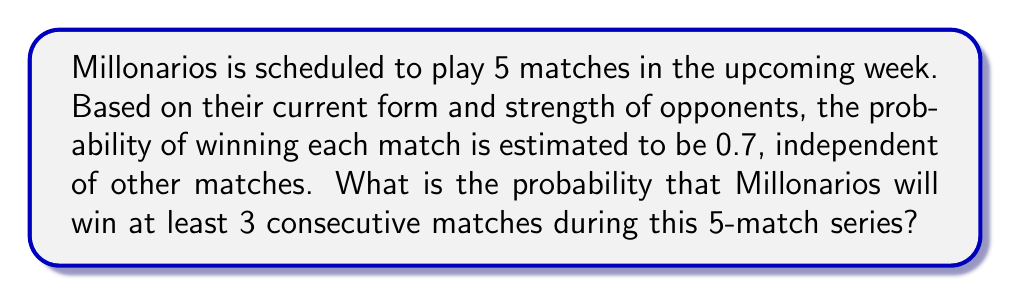Show me your answer to this math problem. Let's approach this step-by-step:

1) First, we need to identify the favorable outcomes. Millonarios can win at least 3 consecutive matches in the following ways:
   - WWWLL, LWWWL, LLWWW, WWWWL, LWWWW, WWWWW
   Where W represents a win and L represents a loss.

2) Now, let's calculate the probability of each of these outcomes:

   $P(\text{WWWLL}) = 0.7 \cdot 0.7 \cdot 0.7 \cdot 0.3 \cdot 0.3 = 0.7^3 \cdot 0.3^2$
   $P(\text{LWWWL}) = 0.3 \cdot 0.7 \cdot 0.7 \cdot 0.7 \cdot 0.3 = 0.3 \cdot 0.7^3 \cdot 0.3$
   $P(\text{LLWWW}) = 0.3 \cdot 0.3 \cdot 0.7 \cdot 0.7 \cdot 0.7 = 0.3^2 \cdot 0.7^3$
   $P(\text{WWWWL}) = 0.7 \cdot 0.7 \cdot 0.7 \cdot 0.7 \cdot 0.3 = 0.7^4 \cdot 0.3$
   $P(\text{LWWWW}) = 0.3 \cdot 0.7 \cdot 0.7 \cdot 0.7 \cdot 0.7 = 0.3 \cdot 0.7^4$
   $P(\text{WWWWW}) = 0.7 \cdot 0.7 \cdot 0.7 \cdot 0.7 \cdot 0.7 = 0.7^5$

3) The total probability is the sum of these individual probabilities:

   $$\begin{align*}
   P(\text{at least 3 consecutive wins}) &= 3 \cdot (0.7^3 \cdot 0.3^2) + 2 \cdot (0.3 \cdot 0.7^4) + 0.7^5 \\
   &= 3 \cdot (0.343 \cdot 0.09) + 2 \cdot (0.3 \cdot 0.2401) + 0.16807 \\
   &= 3 \cdot 0.03087 + 2 \cdot 0.07203 + 0.16807 \\
   &= 0.09261 + 0.14406 + 0.16807 \\
   &= 0.40474
   \end{align*}$$
Answer: The probability that Millonarios will win at least 3 consecutive matches during this 5-match series is approximately 0.4047 or 40.47%. 